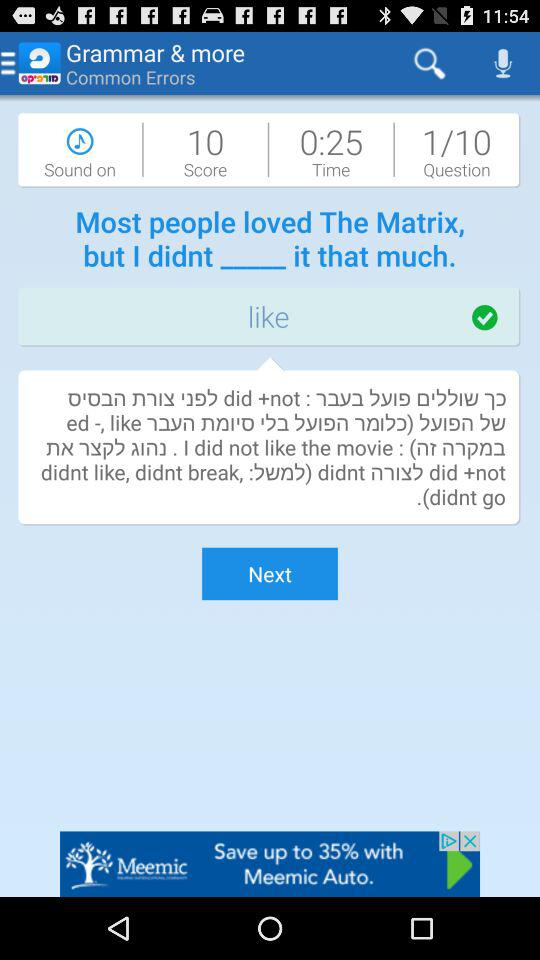What is the status of "Sound"? The status of "Sound" is "on". 